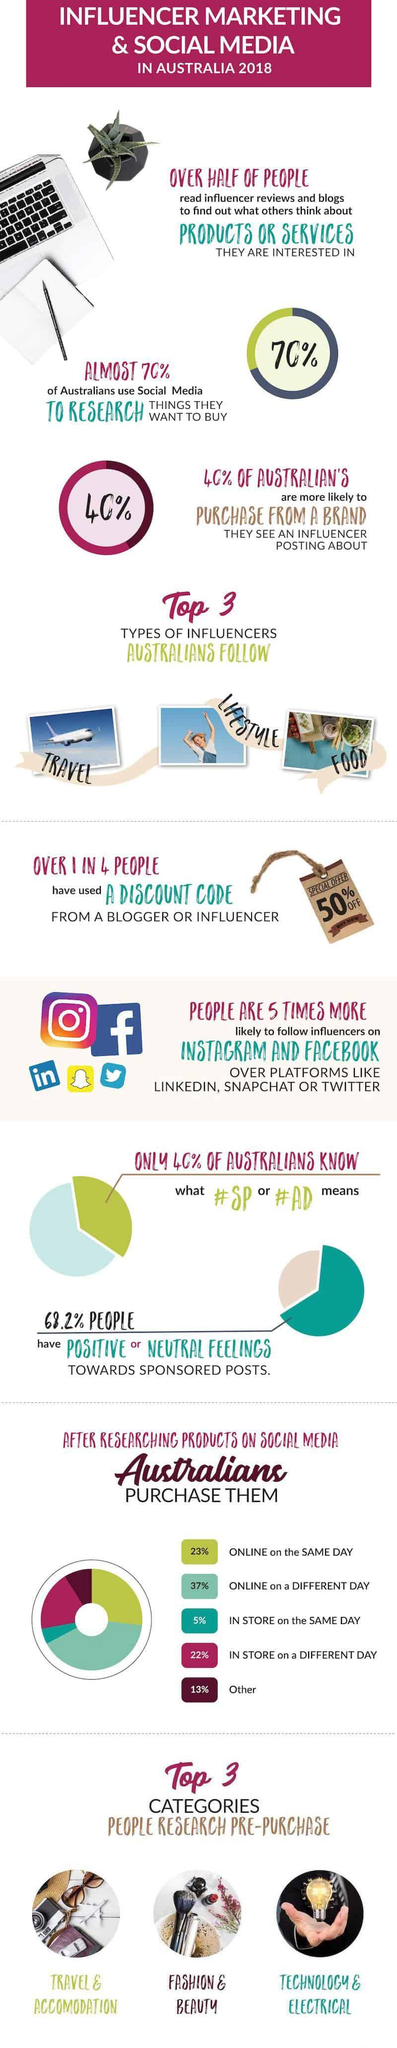Outline some significant characteristics in this image. The percentage of individuals who were online on the same day and online on a different day taken together is 60%. A study has found that Australians are most likely to follow influencers in the travel, lifestyle, and food categories. According to the data, 30% of Australians did not use social media to research things they want to buy. According to the data, 31.8% of people have a negative feeling towards sponsored posts. Out of the 4 people, 3 did not use a discount code from a blogger. 